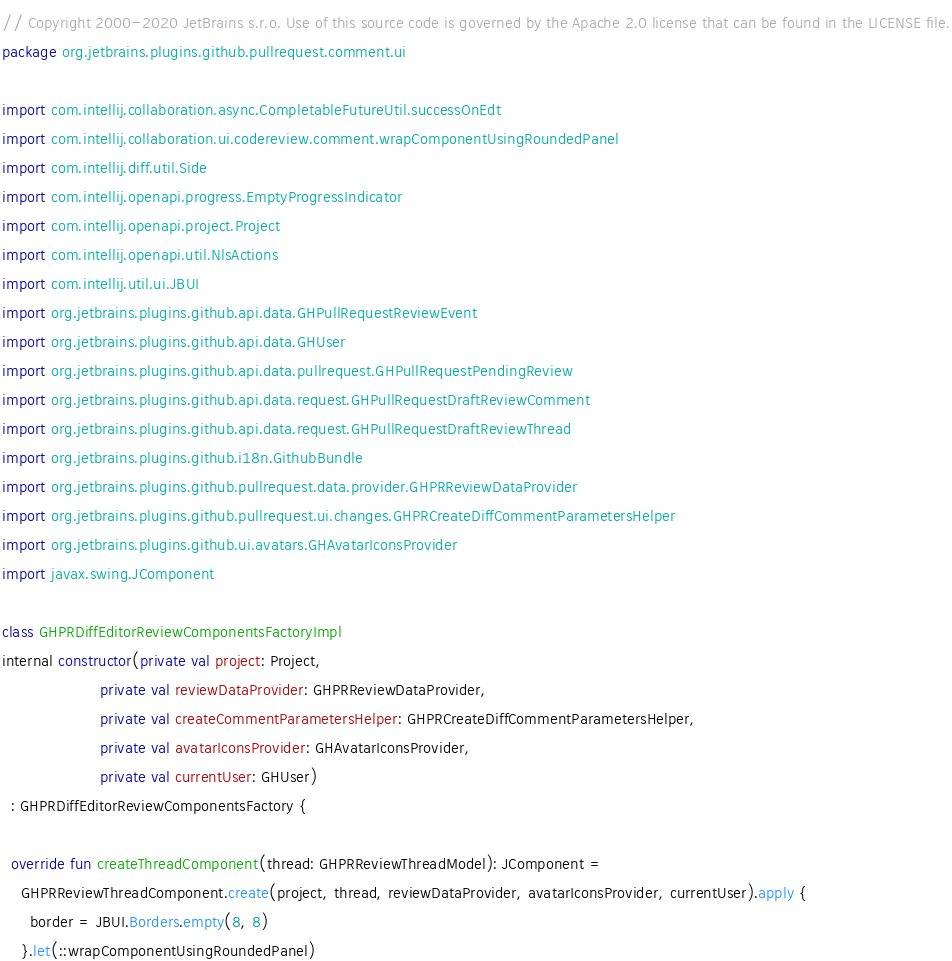Convert code to text. <code><loc_0><loc_0><loc_500><loc_500><_Kotlin_>// Copyright 2000-2020 JetBrains s.r.o. Use of this source code is governed by the Apache 2.0 license that can be found in the LICENSE file.
package org.jetbrains.plugins.github.pullrequest.comment.ui

import com.intellij.collaboration.async.CompletableFutureUtil.successOnEdt
import com.intellij.collaboration.ui.codereview.comment.wrapComponentUsingRoundedPanel
import com.intellij.diff.util.Side
import com.intellij.openapi.progress.EmptyProgressIndicator
import com.intellij.openapi.project.Project
import com.intellij.openapi.util.NlsActions
import com.intellij.util.ui.JBUI
import org.jetbrains.plugins.github.api.data.GHPullRequestReviewEvent
import org.jetbrains.plugins.github.api.data.GHUser
import org.jetbrains.plugins.github.api.data.pullrequest.GHPullRequestPendingReview
import org.jetbrains.plugins.github.api.data.request.GHPullRequestDraftReviewComment
import org.jetbrains.plugins.github.api.data.request.GHPullRequestDraftReviewThread
import org.jetbrains.plugins.github.i18n.GithubBundle
import org.jetbrains.plugins.github.pullrequest.data.provider.GHPRReviewDataProvider
import org.jetbrains.plugins.github.pullrequest.ui.changes.GHPRCreateDiffCommentParametersHelper
import org.jetbrains.plugins.github.ui.avatars.GHAvatarIconsProvider
import javax.swing.JComponent

class GHPRDiffEditorReviewComponentsFactoryImpl
internal constructor(private val project: Project,
                     private val reviewDataProvider: GHPRReviewDataProvider,
                     private val createCommentParametersHelper: GHPRCreateDiffCommentParametersHelper,
                     private val avatarIconsProvider: GHAvatarIconsProvider,
                     private val currentUser: GHUser)
  : GHPRDiffEditorReviewComponentsFactory {

  override fun createThreadComponent(thread: GHPRReviewThreadModel): JComponent =
    GHPRReviewThreadComponent.create(project, thread, reviewDataProvider, avatarIconsProvider, currentUser).apply {
      border = JBUI.Borders.empty(8, 8)
    }.let(::wrapComponentUsingRoundedPanel)
</code> 